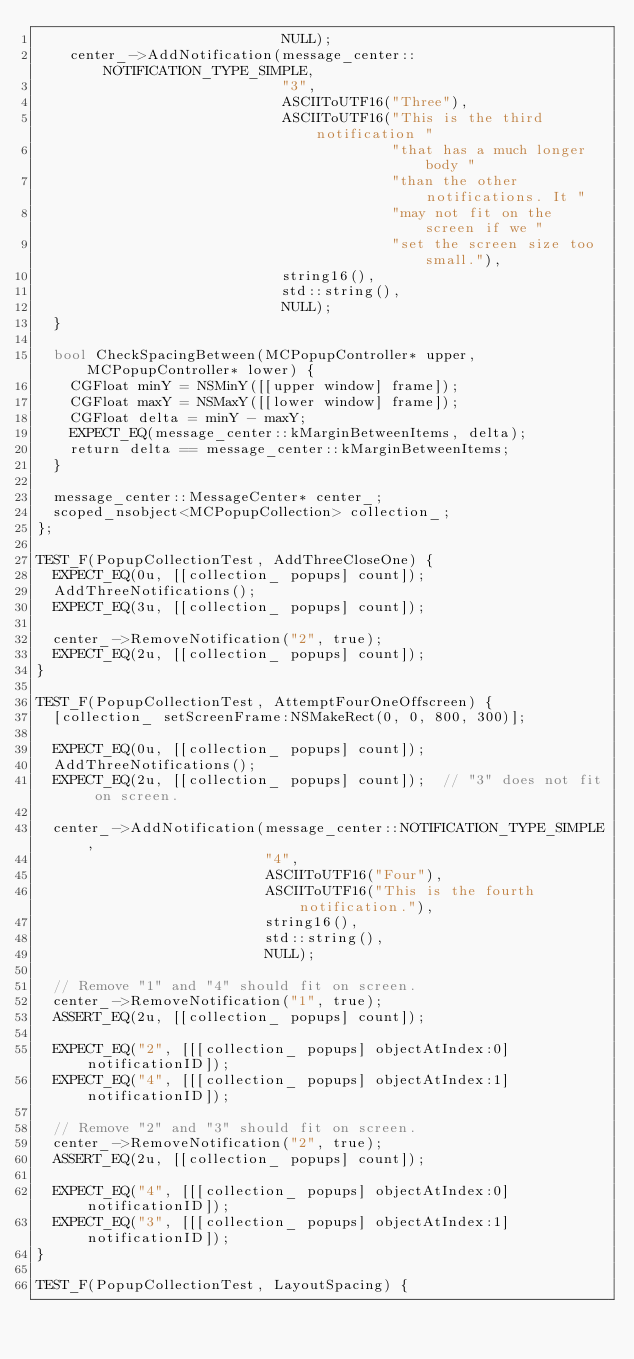Convert code to text. <code><loc_0><loc_0><loc_500><loc_500><_ObjectiveC_>                             NULL);
    center_->AddNotification(message_center::NOTIFICATION_TYPE_SIMPLE,
                             "3",
                             ASCIIToUTF16("Three"),
                             ASCIIToUTF16("This is the third notification "
                                          "that has a much longer body "
                                          "than the other notifications. It "
                                          "may not fit on the screen if we "
                                          "set the screen size too small."),
                             string16(),
                             std::string(),
                             NULL);
  }

  bool CheckSpacingBetween(MCPopupController* upper, MCPopupController* lower) {
    CGFloat minY = NSMinY([[upper window] frame]);
    CGFloat maxY = NSMaxY([[lower window] frame]);
    CGFloat delta = minY - maxY;
    EXPECT_EQ(message_center::kMarginBetweenItems, delta);
    return delta == message_center::kMarginBetweenItems;
  }

  message_center::MessageCenter* center_;
  scoped_nsobject<MCPopupCollection> collection_;
};

TEST_F(PopupCollectionTest, AddThreeCloseOne) {
  EXPECT_EQ(0u, [[collection_ popups] count]);
  AddThreeNotifications();
  EXPECT_EQ(3u, [[collection_ popups] count]);

  center_->RemoveNotification("2", true);
  EXPECT_EQ(2u, [[collection_ popups] count]);
}

TEST_F(PopupCollectionTest, AttemptFourOneOffscreen) {
  [collection_ setScreenFrame:NSMakeRect(0, 0, 800, 300)];

  EXPECT_EQ(0u, [[collection_ popups] count]);
  AddThreeNotifications();
  EXPECT_EQ(2u, [[collection_ popups] count]);  // "3" does not fit on screen.

  center_->AddNotification(message_center::NOTIFICATION_TYPE_SIMPLE,
                           "4",
                           ASCIIToUTF16("Four"),
                           ASCIIToUTF16("This is the fourth notification."),
                           string16(),
                           std::string(),
                           NULL);

  // Remove "1" and "4" should fit on screen.
  center_->RemoveNotification("1", true);
  ASSERT_EQ(2u, [[collection_ popups] count]);

  EXPECT_EQ("2", [[[collection_ popups] objectAtIndex:0] notificationID]);
  EXPECT_EQ("4", [[[collection_ popups] objectAtIndex:1] notificationID]);

  // Remove "2" and "3" should fit on screen.
  center_->RemoveNotification("2", true);
  ASSERT_EQ(2u, [[collection_ popups] count]);

  EXPECT_EQ("4", [[[collection_ popups] objectAtIndex:0] notificationID]);
  EXPECT_EQ("3", [[[collection_ popups] objectAtIndex:1] notificationID]);
}

TEST_F(PopupCollectionTest, LayoutSpacing) {</code> 